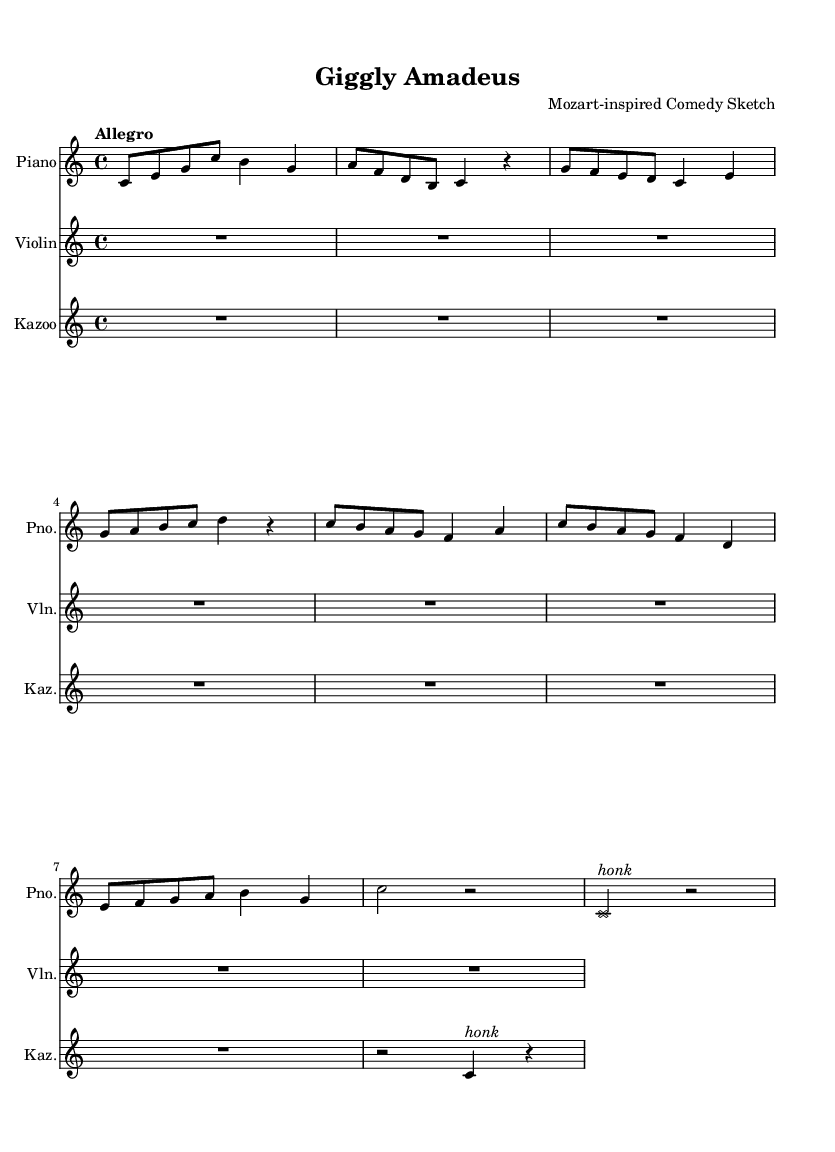What is the key signature of this music? The key signature shows no sharps or flats at the beginning of the staff, indicating it is in C major.
Answer: C major What is the time signature of this music? The time signature appears at the beginning of the piece, showing a 4/4 time signature, meaning there are four beats in each measure.
Answer: 4/4 What is the tempo marking for this piece? The tempo marking "Allegro" is written at the start, indicating a fast and lively speed for the music.
Answer: Allegro How many measures are in the piano part? By counting the individual groups separated by vertical lines (bar lines), there are a total of eight measures in the piano part.
Answer: Eight What instrument is indicated to play the "honk" effect? The kazoo part includes a notable "honk" marking above the note, suggesting it’s meant for the kazoo to amplify humor.
Answer: Kazoo What is the movement style of this composition? The lively and playful nature, indicated by the tempo and the instrument choices, suggests a light-hearted or comedic movement style throughout the piece.
Answer: Comedic How long is the rest in the kazoo part? The rest notation in the kazoo part is two beats long, depicted clearly after the first rest before the kazoo plays a note.
Answer: Two beats 